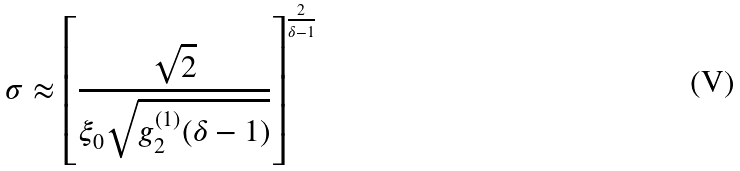Convert formula to latex. <formula><loc_0><loc_0><loc_500><loc_500>\sigma \approx \left [ \frac { \sqrt { 2 } } { \xi _ { 0 } \sqrt { g _ { 2 } ^ { ( 1 ) } ( \delta - 1 ) } } \right ] ^ { \frac { 2 } { \delta - 1 } }</formula> 